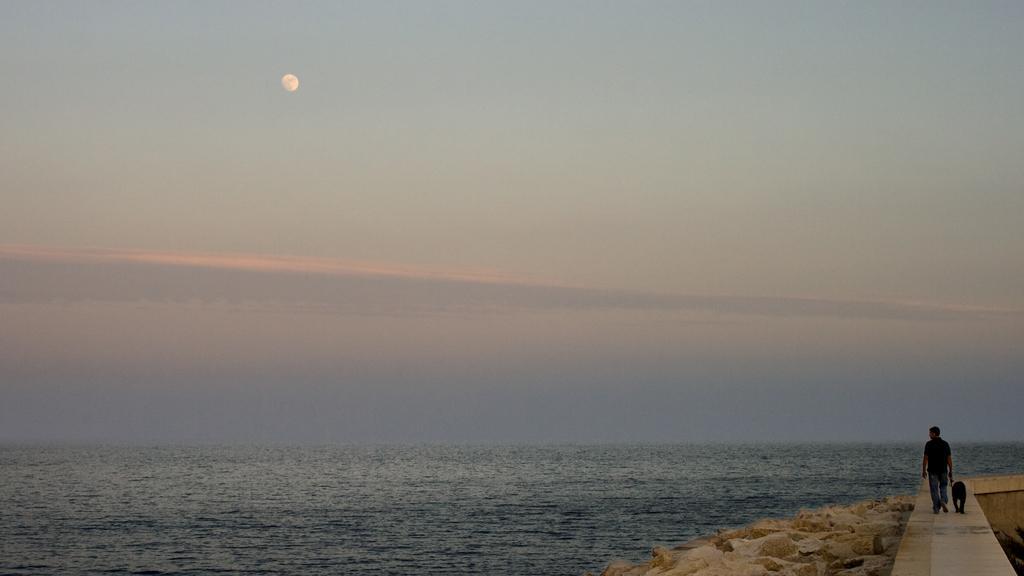How would you summarize this image in a sentence or two? There is a sea and a person is walking on a path along with his dog beside the sea shore. 